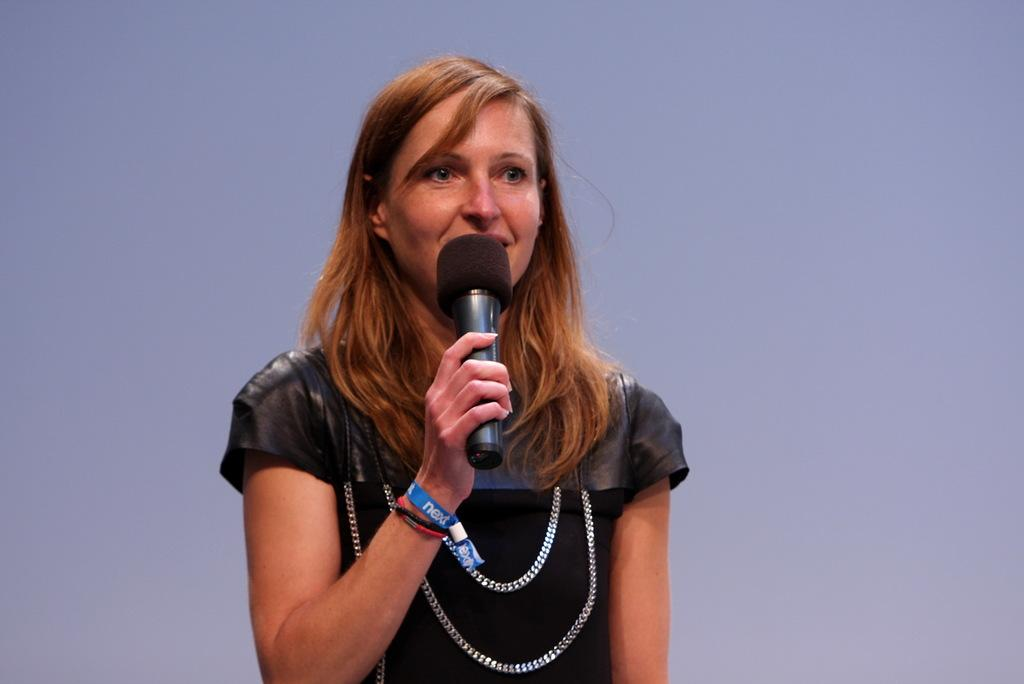What is the woman in the image doing? The woman is standing and talking in the image. What is the woman holding in the image? The woman is holding a microphone in the image. What can be seen in the background of the image? There is a wall in the background of the image. What type of sugar is being used to sweeten the pies in the image? There are no pies or sugar present in the image; it features a woman standing and talking while holding a microphone. What color is the woman's skirt in the image? The image does not show the woman's skirt, as she is standing and talking while holding a microphone. 